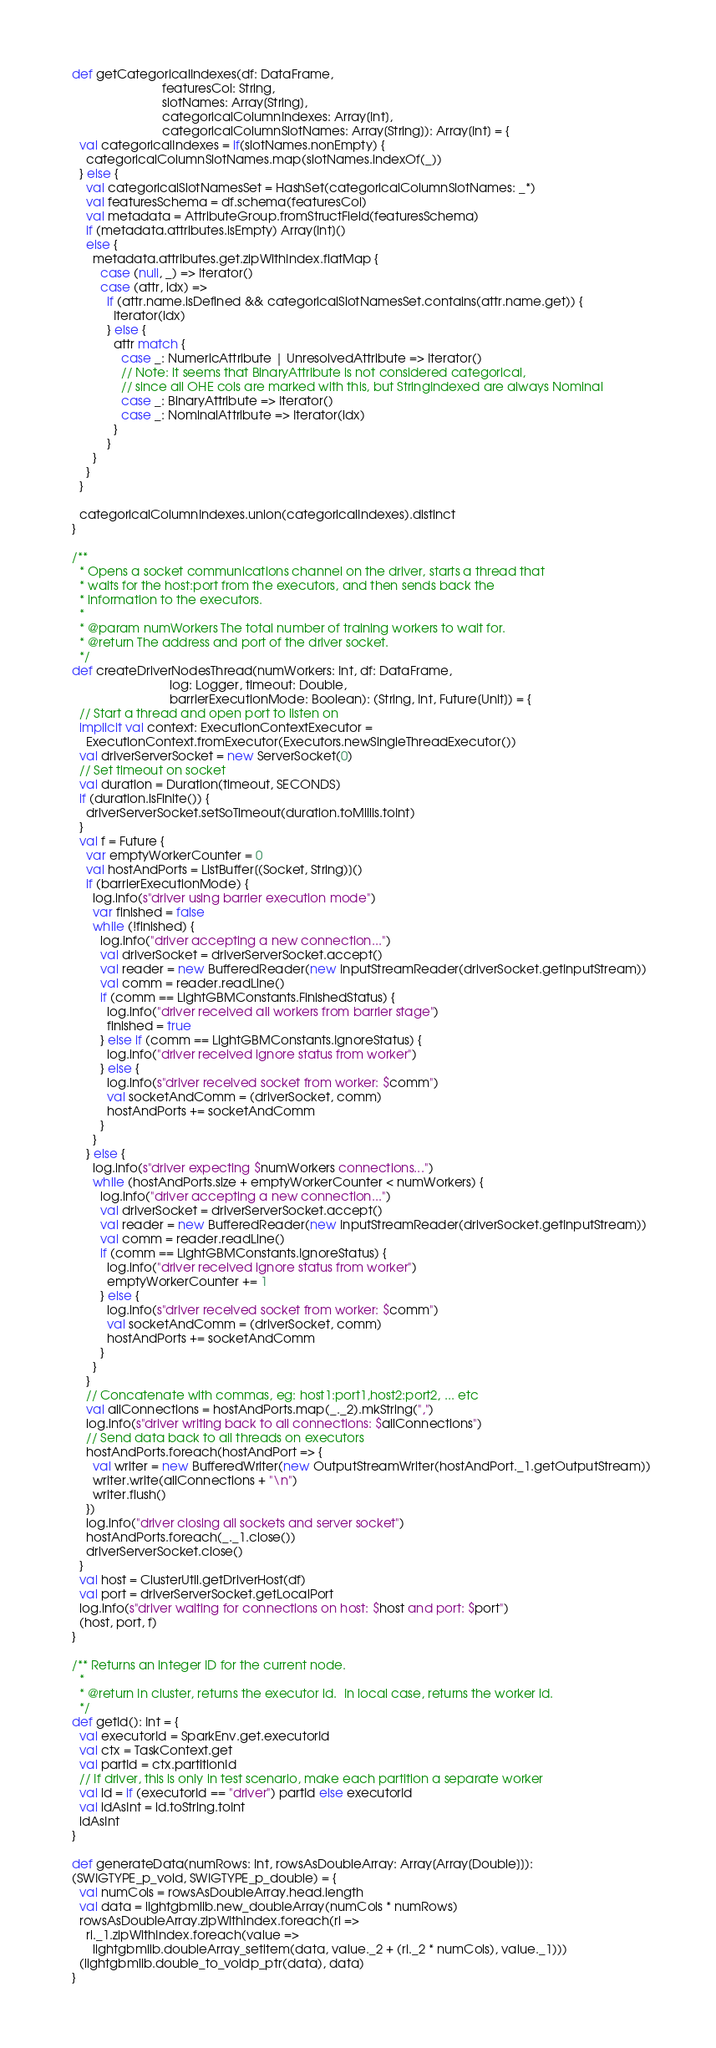<code> <loc_0><loc_0><loc_500><loc_500><_Scala_>  def getCategoricalIndexes(df: DataFrame,
                            featuresCol: String,
                            slotNames: Array[String],
                            categoricalColumnIndexes: Array[Int],
                            categoricalColumnSlotNames: Array[String]): Array[Int] = {
    val categoricalIndexes = if(slotNames.nonEmpty) {
      categoricalColumnSlotNames.map(slotNames.indexOf(_))
    } else {
      val categoricalSlotNamesSet = HashSet(categoricalColumnSlotNames: _*)
      val featuresSchema = df.schema(featuresCol)
      val metadata = AttributeGroup.fromStructField(featuresSchema)
      if (metadata.attributes.isEmpty) Array[Int]()
      else {
        metadata.attributes.get.zipWithIndex.flatMap {
          case (null, _) => Iterator()
          case (attr, idx) =>
            if (attr.name.isDefined && categoricalSlotNamesSet.contains(attr.name.get)) {
              Iterator(idx)
            } else {
              attr match {
                case _: NumericAttribute | UnresolvedAttribute => Iterator()
                // Note: it seems that BinaryAttribute is not considered categorical,
                // since all OHE cols are marked with this, but StringIndexed are always Nominal
                case _: BinaryAttribute => Iterator()
                case _: NominalAttribute => Iterator(idx)
              }
            }
        }
      }
    }

    categoricalColumnIndexes.union(categoricalIndexes).distinct
  }

  /**
    * Opens a socket communications channel on the driver, starts a thread that
    * waits for the host:port from the executors, and then sends back the
    * information to the executors.
    *
    * @param numWorkers The total number of training workers to wait for.
    * @return The address and port of the driver socket.
    */
  def createDriverNodesThread(numWorkers: Int, df: DataFrame,
                              log: Logger, timeout: Double,
                              barrierExecutionMode: Boolean): (String, Int, Future[Unit]) = {
    // Start a thread and open port to listen on
    implicit val context: ExecutionContextExecutor =
      ExecutionContext.fromExecutor(Executors.newSingleThreadExecutor())
    val driverServerSocket = new ServerSocket(0)
    // Set timeout on socket
    val duration = Duration(timeout, SECONDS)
    if (duration.isFinite()) {
      driverServerSocket.setSoTimeout(duration.toMillis.toInt)
    }
    val f = Future {
      var emptyWorkerCounter = 0
      val hostAndPorts = ListBuffer[(Socket, String)]()
      if (barrierExecutionMode) {
        log.info(s"driver using barrier execution mode")
        var finished = false
        while (!finished) {
          log.info("driver accepting a new connection...")
          val driverSocket = driverServerSocket.accept()
          val reader = new BufferedReader(new InputStreamReader(driverSocket.getInputStream))
          val comm = reader.readLine()
          if (comm == LightGBMConstants.FinishedStatus) {
            log.info("driver received all workers from barrier stage")
            finished = true
          } else if (comm == LightGBMConstants.IgnoreStatus) {
            log.info("driver received ignore status from worker")
          } else {
            log.info(s"driver received socket from worker: $comm")
            val socketAndComm = (driverSocket, comm)
            hostAndPorts += socketAndComm
          }
        }
      } else {
        log.info(s"driver expecting $numWorkers connections...")
        while (hostAndPorts.size + emptyWorkerCounter < numWorkers) {
          log.info("driver accepting a new connection...")
          val driverSocket = driverServerSocket.accept()
          val reader = new BufferedReader(new InputStreamReader(driverSocket.getInputStream))
          val comm = reader.readLine()
          if (comm == LightGBMConstants.IgnoreStatus) {
            log.info("driver received ignore status from worker")
            emptyWorkerCounter += 1
          } else {
            log.info(s"driver received socket from worker: $comm")
            val socketAndComm = (driverSocket, comm)
            hostAndPorts += socketAndComm
          }
        }
      }
      // Concatenate with commas, eg: host1:port1,host2:port2, ... etc
      val allConnections = hostAndPorts.map(_._2).mkString(",")
      log.info(s"driver writing back to all connections: $allConnections")
      // Send data back to all threads on executors
      hostAndPorts.foreach(hostAndPort => {
        val writer = new BufferedWriter(new OutputStreamWriter(hostAndPort._1.getOutputStream))
        writer.write(allConnections + "\n")
        writer.flush()
      })
      log.info("driver closing all sockets and server socket")
      hostAndPorts.foreach(_._1.close())
      driverServerSocket.close()
    }
    val host = ClusterUtil.getDriverHost(df)
    val port = driverServerSocket.getLocalPort
    log.info(s"driver waiting for connections on host: $host and port: $port")
    (host, port, f)
  }

  /** Returns an integer ID for the current node.
    *
    * @return In cluster, returns the executor id.  In local case, returns the worker id.
    */
  def getId(): Int = {
    val executorId = SparkEnv.get.executorId
    val ctx = TaskContext.get
    val partId = ctx.partitionId
    // If driver, this is only in test scenario, make each partition a separate worker
    val id = if (executorId == "driver") partId else executorId
    val idAsInt = id.toString.toInt
    idAsInt
  }

  def generateData(numRows: Int, rowsAsDoubleArray: Array[Array[Double]]):
  (SWIGTYPE_p_void, SWIGTYPE_p_double) = {
    val numCols = rowsAsDoubleArray.head.length
    val data = lightgbmlib.new_doubleArray(numCols * numRows)
    rowsAsDoubleArray.zipWithIndex.foreach(ri =>
      ri._1.zipWithIndex.foreach(value =>
        lightgbmlib.doubleArray_setitem(data, value._2 + (ri._2 * numCols), value._1)))
    (lightgbmlib.double_to_voidp_ptr(data), data)
  }
</code> 